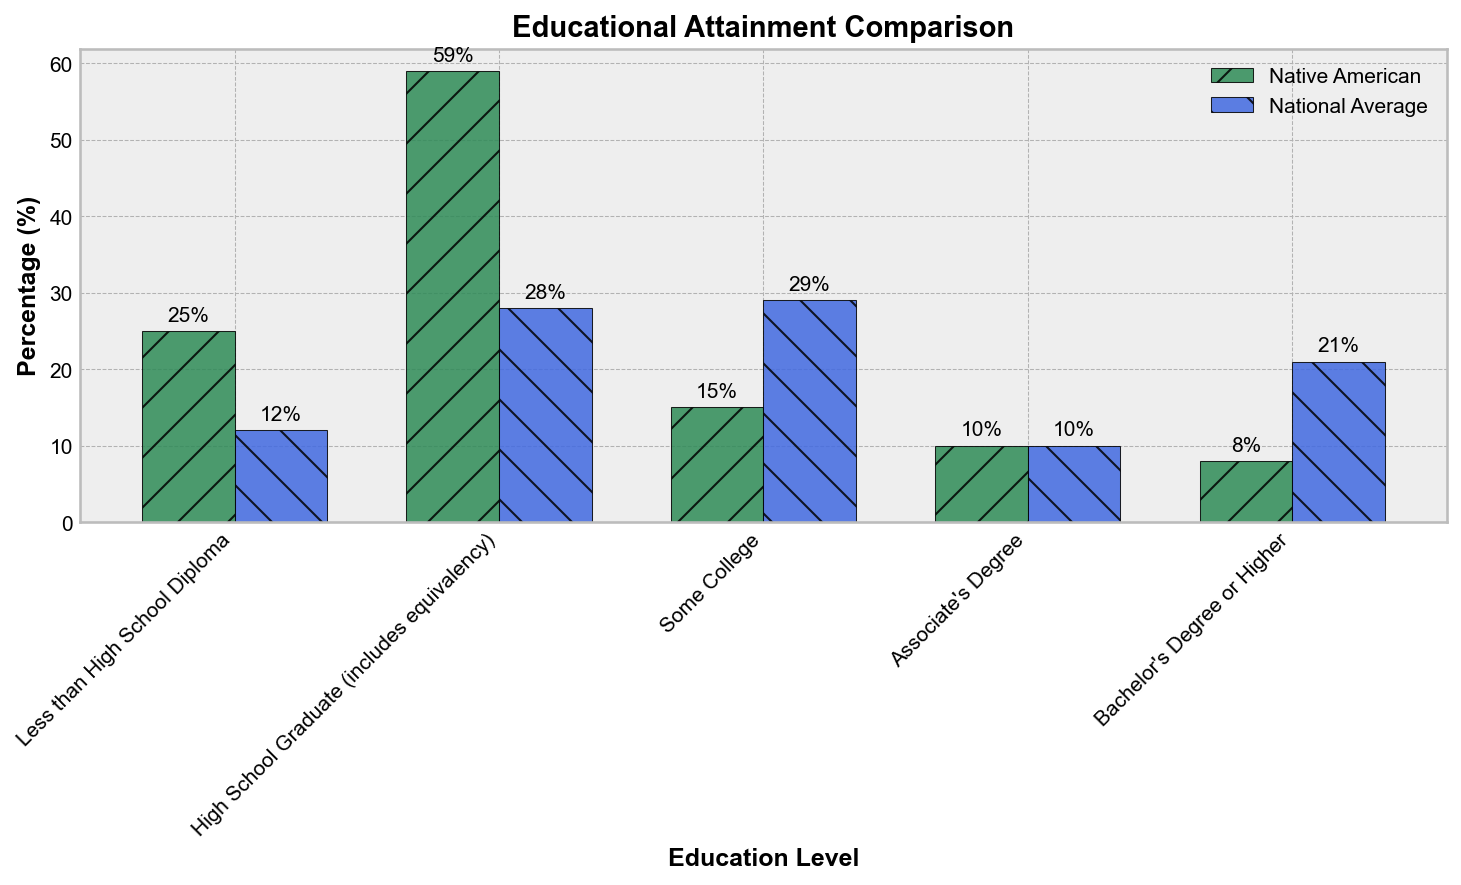What percentage of Native Americans have a high school diploma or higher? First, add the percentages of Native Americans with "High School Graduate", "Some College", "Associate's Degree", and "Bachelor's Degree or Higher". Hence, 59% + 15% + 10% + 8% = 92%.
Answer: 92% Which group has a higher percentage of people with some college education, Native Americans or the national average? Compare the percentage for "Some College" between Native Americans (15%) and the national average (29%).
Answer: National Average How much higher is the national average for individuals with a Bachelor's degree or higher compared to Native Americans? Subtract the percentage of Native Americans with a Bachelor's degree or higher (8%) from the national average (21%). Thus, 21% - 8% = 13%.
Answer: 13% What is the percentage difference between Native Americans and the national average for high school graduates? Subtract the national average percentage for "High School Graduate" (28%) from the Native American percentage (59%). Thus, 59% - 28% = 31%.
Answer: 31% Which education level shows the closest similarity between Native Americans and the national average, and what are those percentages? Identify the pairs of percentages and find the minimum difference. "Associate's Degree" for both Native Americans and the national average is 10%.
Answer: Associate's Degree, 10% What is the total percentage of Native Americans who have achieved some form of higher education (Associate's Degree or higher)? Add the percentages for "Associate's Degree" and "Bachelor's Degree or Higher". Therefore, 10% + 8% = 18%.
Answer: 18% Compare the discrepancies in percentages between Native Americans and the national average for those with less than a high school diploma. Calculate the difference between 25% (Native Americans) and 12% (national average). Thus, 25% - 12% = 13%.
Answer: 13% Which has a higher percentage of high school graduates, Native Americans or the national average, and by how much? Compare 59% (Native Americans) to 28% (national average) and find the difference. Thus, 59% - 28% = 31%.
Answer: Native Americans by 31% Which color represents the Native American data on the plot? The bars representing Native Americans are colored in seagreen.
Answer: Seagreen How many levels of education are depicted in the figure? Count the categories displayed on the x-axis: "Less than High School Diploma", "High School Graduate", "Some College", "Associate's Degree", "Bachelor's Degree or Higher" (total 5).
Answer: 5 